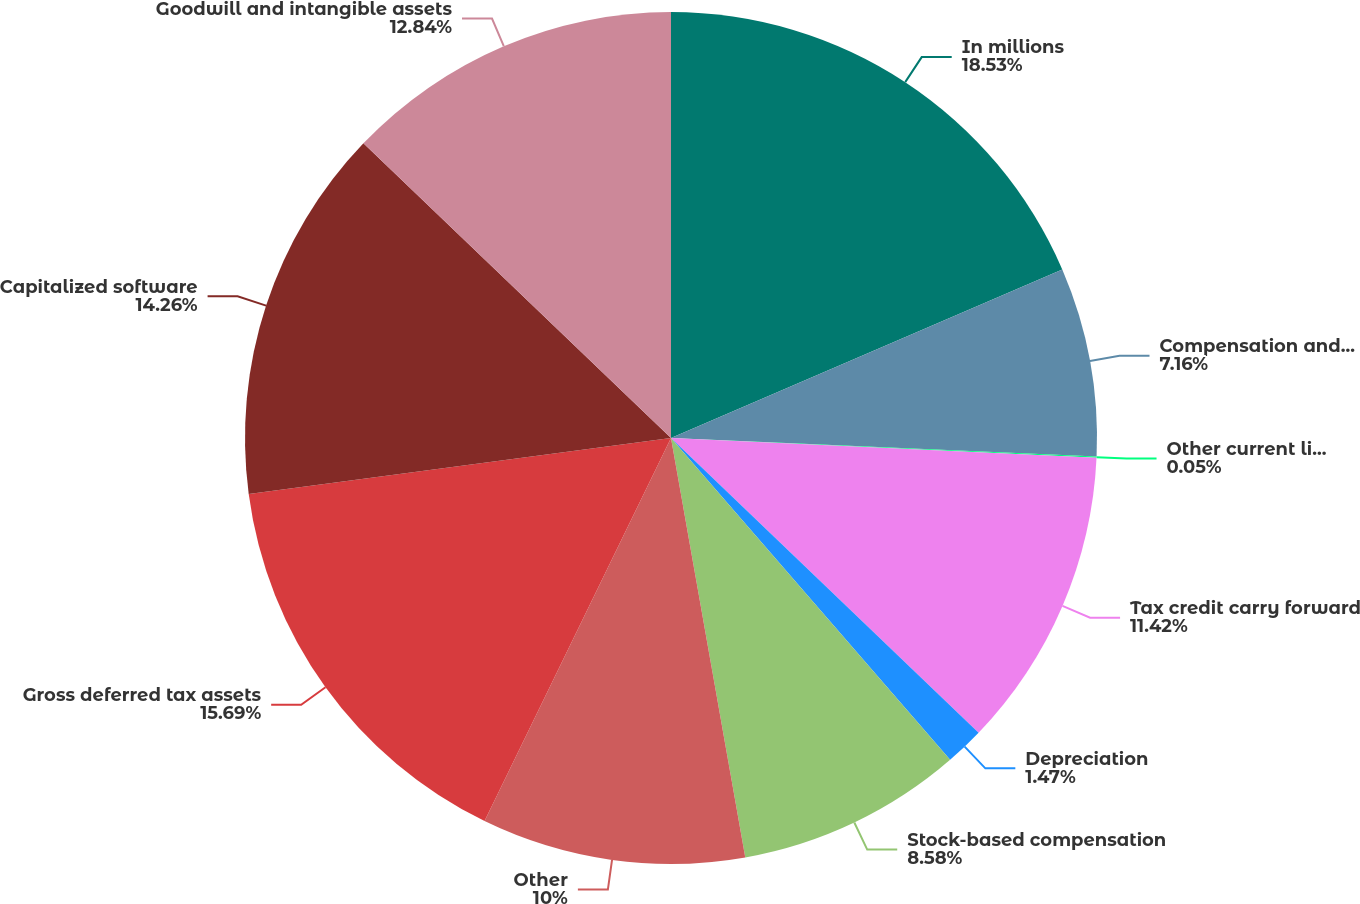Convert chart. <chart><loc_0><loc_0><loc_500><loc_500><pie_chart><fcel>In millions<fcel>Compensation and employee<fcel>Other current liabilities<fcel>Tax credit carry forward<fcel>Depreciation<fcel>Stock-based compensation<fcel>Other<fcel>Gross deferred tax assets<fcel>Capitalized software<fcel>Goodwill and intangible assets<nl><fcel>18.53%<fcel>7.16%<fcel>0.05%<fcel>11.42%<fcel>1.47%<fcel>8.58%<fcel>10.0%<fcel>15.69%<fcel>14.26%<fcel>12.84%<nl></chart> 